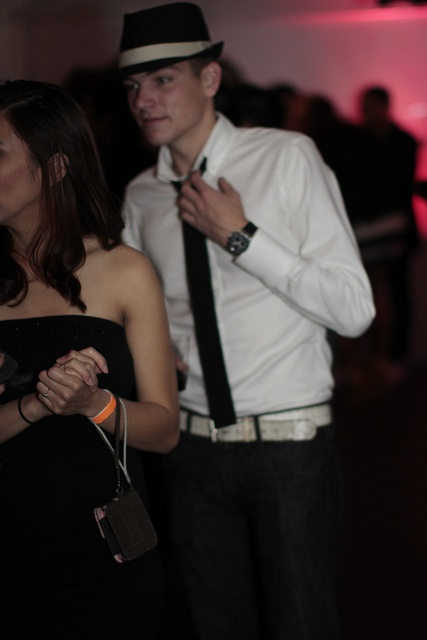Describe the objects in this image and their specific colors. I can see people in black, darkgray, gray, and maroon tones, people in black, maroon, gray, and brown tones, people in black, maroon, and brown tones, tie in black, gray, and teal tones, and handbag in black, gray, and maroon tones in this image. 